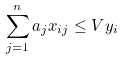<formula> <loc_0><loc_0><loc_500><loc_500>\sum _ { j = 1 } ^ { n } a _ { j } x _ { i j } \leq V y _ { i }</formula> 